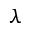<formula> <loc_0><loc_0><loc_500><loc_500>\lambda</formula> 